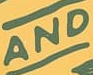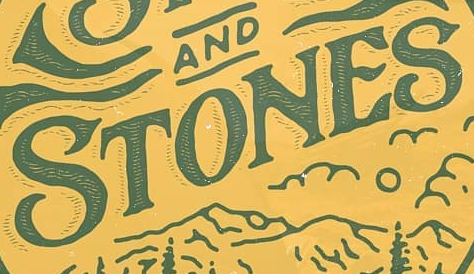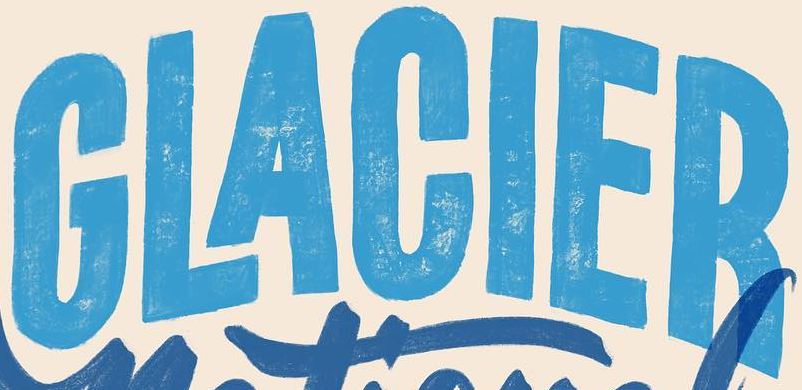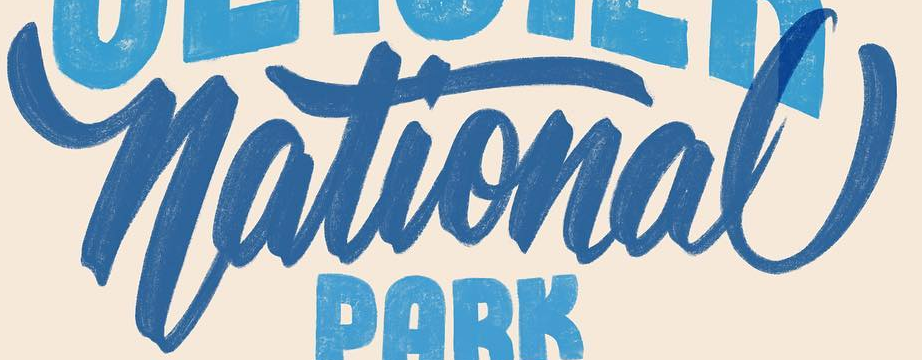Read the text content from these images in order, separated by a semicolon. AND; STONES; GLACIER; National 